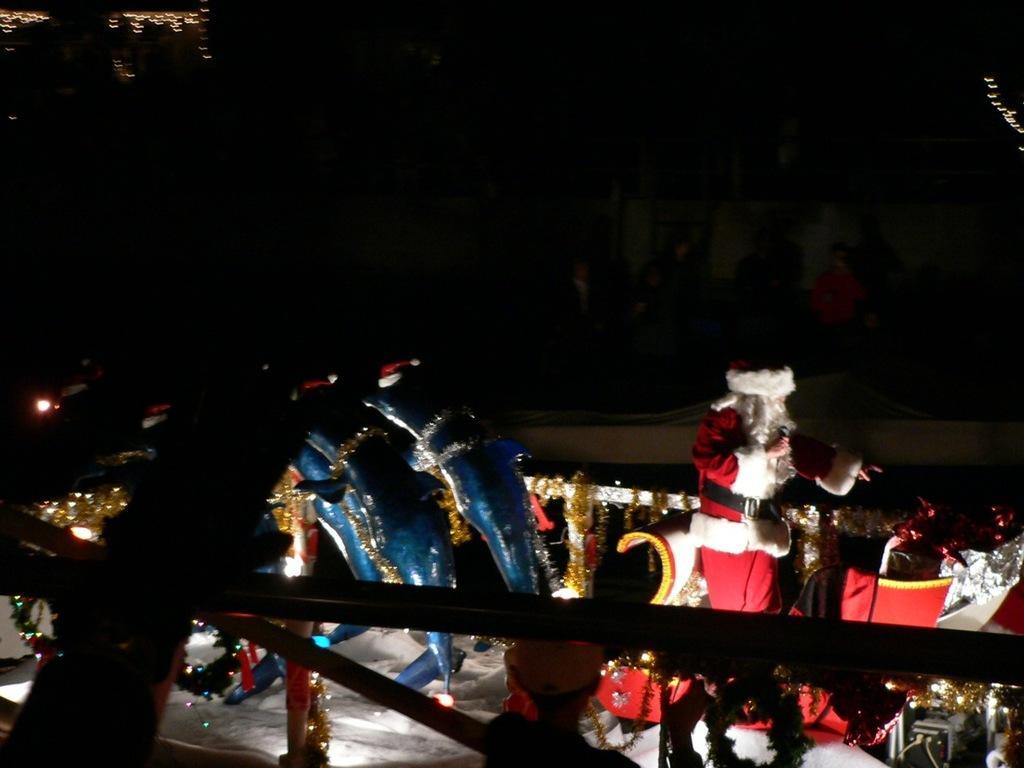How would you summarize this image in a sentence or two? In this picture I can see a person, there are toy dolphins with Christmas hats, there is a Santa Claus on the sleigh, and there is dark background. 